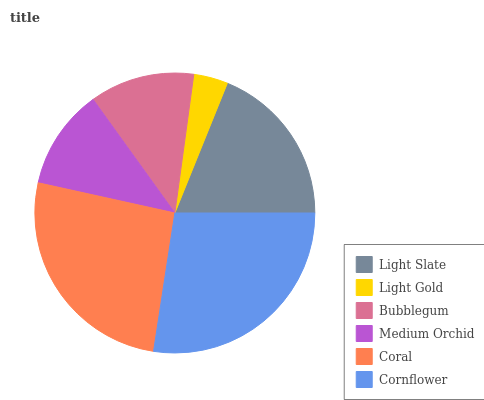Is Light Gold the minimum?
Answer yes or no. Yes. Is Cornflower the maximum?
Answer yes or no. Yes. Is Bubblegum the minimum?
Answer yes or no. No. Is Bubblegum the maximum?
Answer yes or no. No. Is Bubblegum greater than Light Gold?
Answer yes or no. Yes. Is Light Gold less than Bubblegum?
Answer yes or no. Yes. Is Light Gold greater than Bubblegum?
Answer yes or no. No. Is Bubblegum less than Light Gold?
Answer yes or no. No. Is Light Slate the high median?
Answer yes or no. Yes. Is Bubblegum the low median?
Answer yes or no. Yes. Is Cornflower the high median?
Answer yes or no. No. Is Light Slate the low median?
Answer yes or no. No. 